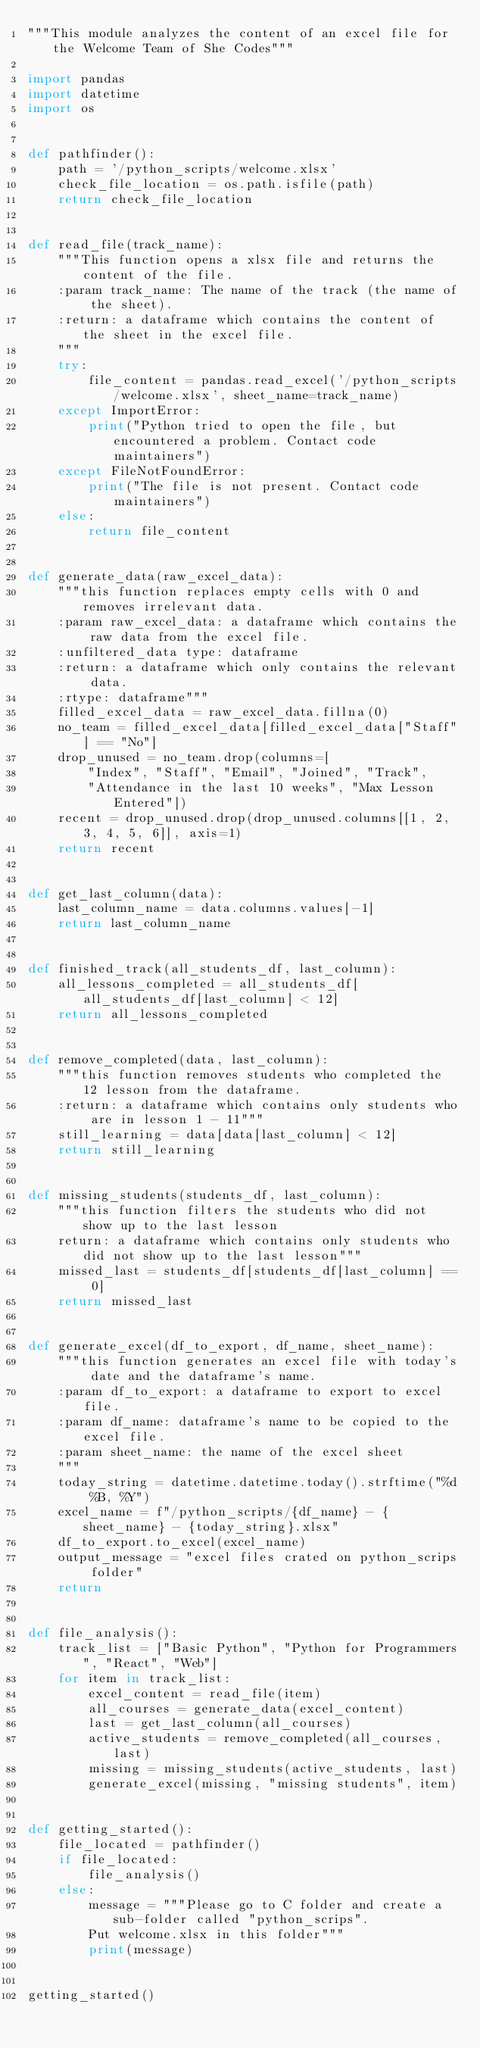<code> <loc_0><loc_0><loc_500><loc_500><_Python_>"""This module analyzes the content of an excel file for the Welcome Team of She Codes"""

import pandas
import datetime
import os


def pathfinder():
    path = '/python_scripts/welcome.xlsx'
    check_file_location = os.path.isfile(path)
    return check_file_location


def read_file(track_name):
    """This function opens a xlsx file and returns the content of the file. 
    :param track_name: The name of the track (the name of the sheet).
    :return: a dataframe which contains the content of the sheet in the excel file.
    """
    try:
        file_content = pandas.read_excel('/python_scripts/welcome.xlsx', sheet_name=track_name)
    except ImportError:
        print("Python tried to open the file, but encountered a problem. Contact code maintainers")
    except FileNotFoundError:
        print("The file is not present. Contact code maintainers")
    else:
        return file_content


def generate_data(raw_excel_data):
    """this function replaces empty cells with 0 and removes irrelevant data.
    :param raw_excel_data: a dataframe which contains the raw data from the excel file.
    :unfiltered_data type: dataframe
    :return: a dataframe which only contains the relevant data.
    :rtype: dataframe"""
    filled_excel_data = raw_excel_data.fillna(0)
    no_team = filled_excel_data[filled_excel_data["Staff"] == "No"]
    drop_unused = no_team.drop(columns=[
        "Index", "Staff", "Email", "Joined", "Track",
        "Attendance in the last 10 weeks", "Max Lesson Entered"])
    recent = drop_unused.drop(drop_unused.columns[[1, 2, 3, 4, 5, 6]], axis=1)
    return recent


def get_last_column(data):
    last_column_name = data.columns.values[-1]
    return last_column_name


def finished_track(all_students_df, last_column):
    all_lessons_completed = all_students_df[all_students_df[last_column] < 12]
    return all_lessons_completed


def remove_completed(data, last_column):
    """this function removes students who completed the 12 lesson from the dataframe.
    :return: a dataframe which contains only students who are in lesson 1 - 11"""
    still_learning = data[data[last_column] < 12]
    return still_learning


def missing_students(students_df, last_column):
    """this function filters the students who did not show up to the last lesson 
    return: a dataframe which contains only students who did not show up to the last lesson"""
    missed_last = students_df[students_df[last_column] == 0]
    return missed_last


def generate_excel(df_to_export, df_name, sheet_name):
    """this function generates an excel file with today's date and the dataframe's name.
    :param df_to_export: a dataframe to export to excel file. 
    :param df_name: dataframe's name to be copied to the excel file.
    :param sheet_name: the name of the excel sheet
    """
    today_string = datetime.datetime.today().strftime("%d %B, %Y")
    excel_name = f"/python_scripts/{df_name} - {sheet_name} - {today_string}.xlsx"
    df_to_export.to_excel(excel_name)
    output_message = "excel files crated on python_scrips folder"
    return


def file_analysis():
    track_list = ["Basic Python", "Python for Programmers", "React", "Web"]
    for item in track_list:
        excel_content = read_file(item)
        all_courses = generate_data(excel_content)
        last = get_last_column(all_courses)
        active_students = remove_completed(all_courses, last)
        missing = missing_students(active_students, last)
        generate_excel(missing, "missing students", item)


def getting_started():
    file_located = pathfinder()
    if file_located:
        file_analysis()
    else:
        message = """Please go to C folder and create a sub-folder called "python_scrips".
        Put welcome.xlsx in this folder"""
        print(message)


getting_started()
</code> 